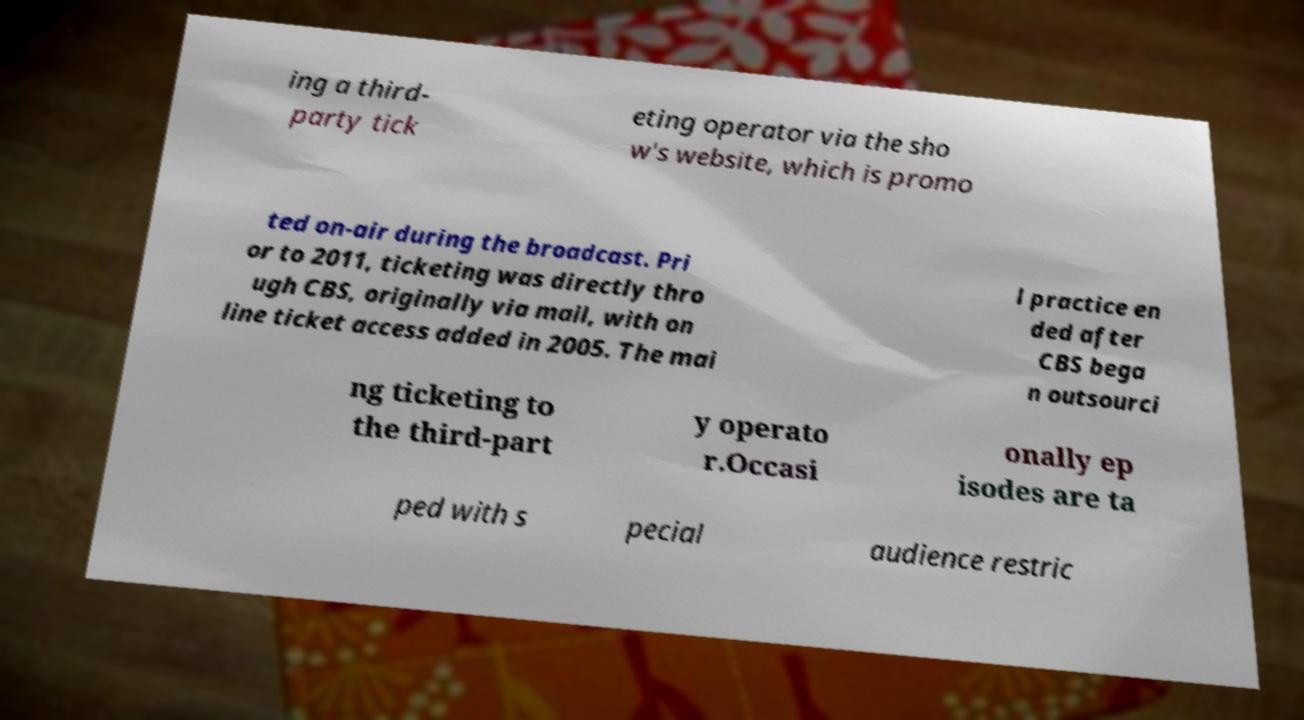Could you extract and type out the text from this image? ing a third- party tick eting operator via the sho w's website, which is promo ted on-air during the broadcast. Pri or to 2011, ticketing was directly thro ugh CBS, originally via mail, with on line ticket access added in 2005. The mai l practice en ded after CBS bega n outsourci ng ticketing to the third-part y operato r.Occasi onally ep isodes are ta ped with s pecial audience restric 